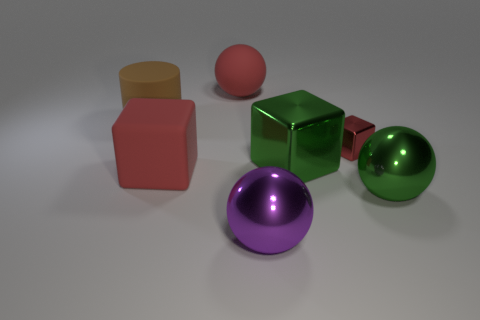What number of big cubes are the same color as the rubber ball?
Your answer should be compact. 1. Are there any other things that are made of the same material as the big green cube?
Make the answer very short. Yes. Does the cube that is on the left side of the big purple sphere have the same material as the green sphere?
Offer a terse response. No. The green object that is to the left of the green metal object in front of the red rubber object in front of the green cube is made of what material?
Provide a succinct answer. Metal. What number of other things are there of the same shape as the brown object?
Your answer should be compact. 0. There is a large matte ball on the right side of the rubber cylinder; what is its color?
Provide a short and direct response. Red. There is a large object that is left of the red block left of the purple metal ball; what number of purple things are right of it?
Your answer should be very brief. 1. There is a red block right of the big red rubber ball; how many large green shiny balls are behind it?
Ensure brevity in your answer.  0. There is a tiny red block; what number of big purple things are behind it?
Your answer should be very brief. 0. What number of other things are the same size as the purple metallic object?
Offer a very short reply. 5. 